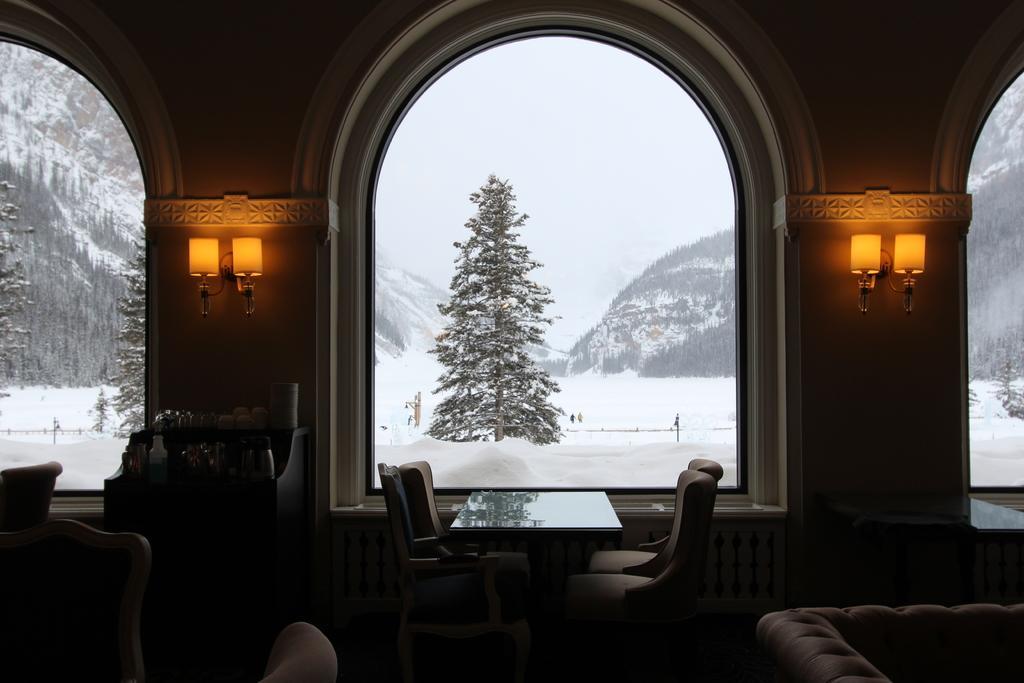Describe this image in one or two sentences. In this picture there are lamps on the right and left side of the image and there are glass windows in the image and there is sofa at the bottom side of the image and there is a table and chairs in the center of the image, there are trees which are covered with snow outside the windows. 